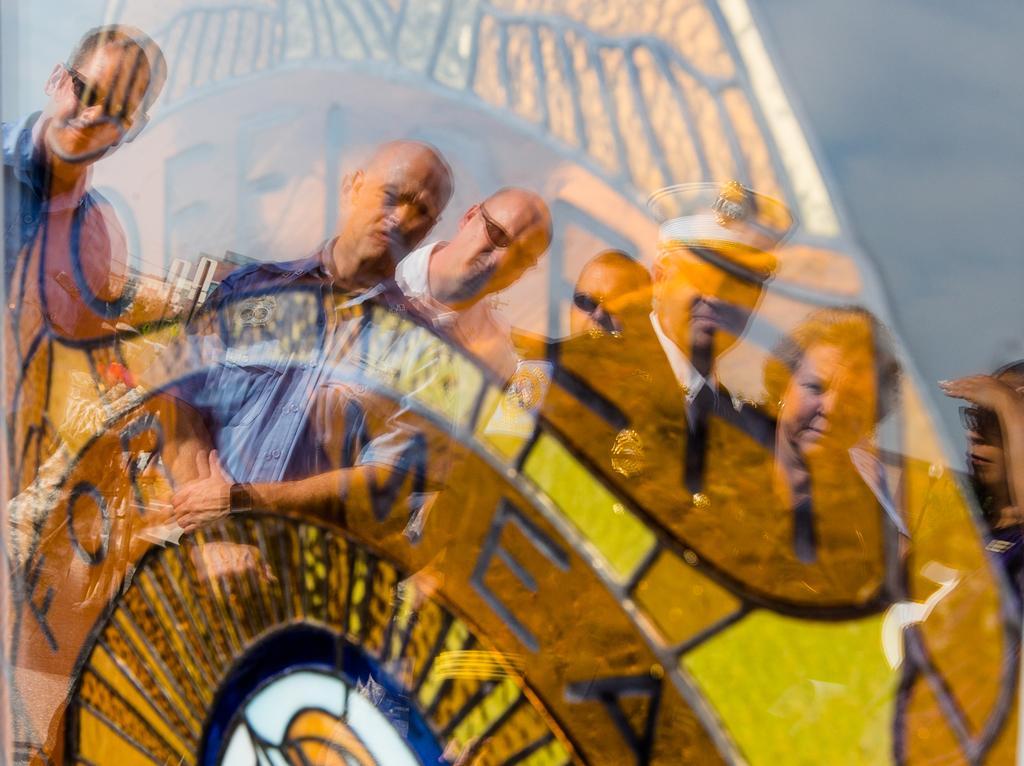Describe this image in one or two sentences. There is a glass and some poster is attached behind the glass and the images of few people are being reflected on the glass. 